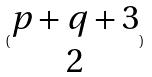<formula> <loc_0><loc_0><loc_500><loc_500>( \begin{matrix} p + q + 3 \\ 2 \end{matrix} )</formula> 